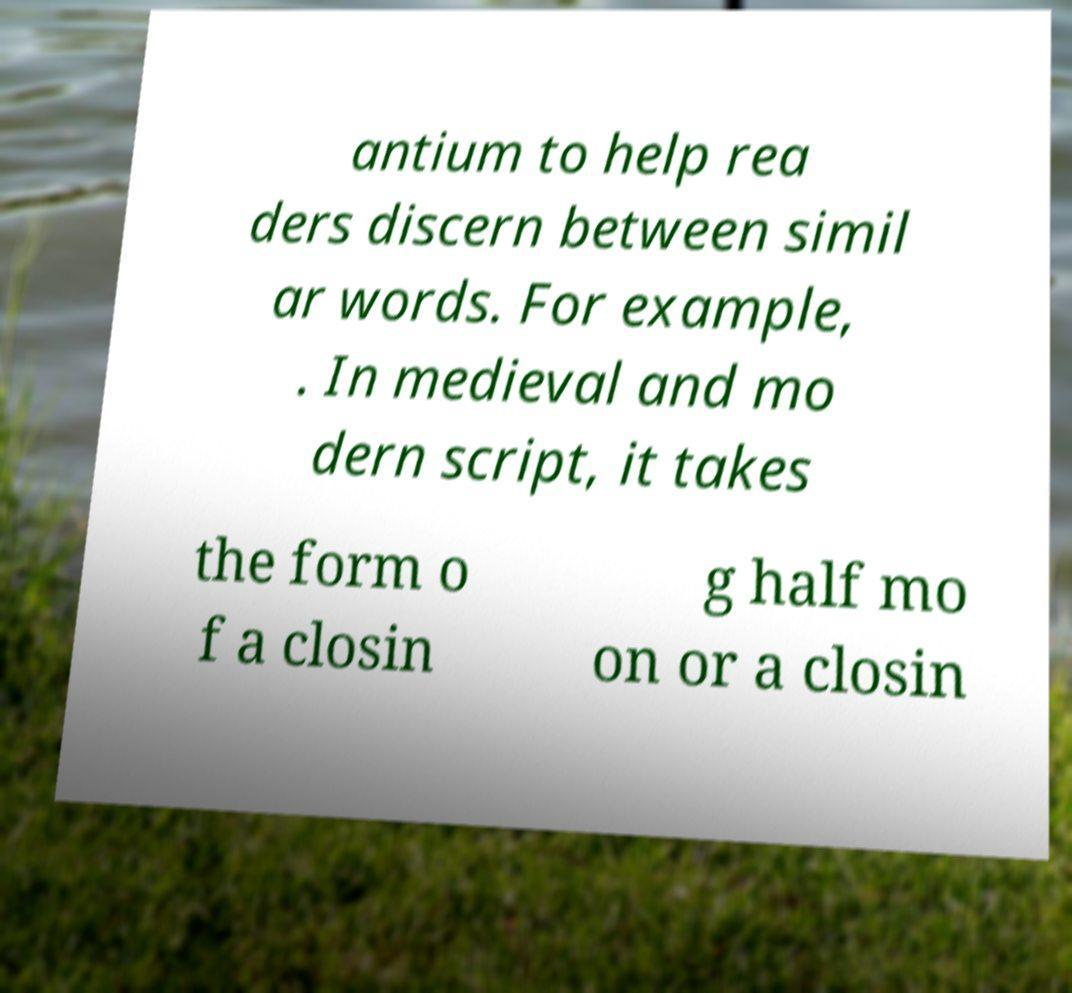Please read and relay the text visible in this image. What does it say? antium to help rea ders discern between simil ar words. For example, . In medieval and mo dern script, it takes the form o f a closin g half mo on or a closin 